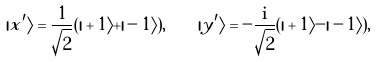<formula> <loc_0><loc_0><loc_500><loc_500>| x ^ { \prime } \rangle = \frac { 1 } { \sqrt { 2 } } ( | + 1 \rangle + | - 1 \rangle ) , \quad | y ^ { \prime } \rangle = - \frac { \mathrm i } { \sqrt { 2 } } ( | + 1 \rangle - | - 1 \rangle ) ,</formula> 